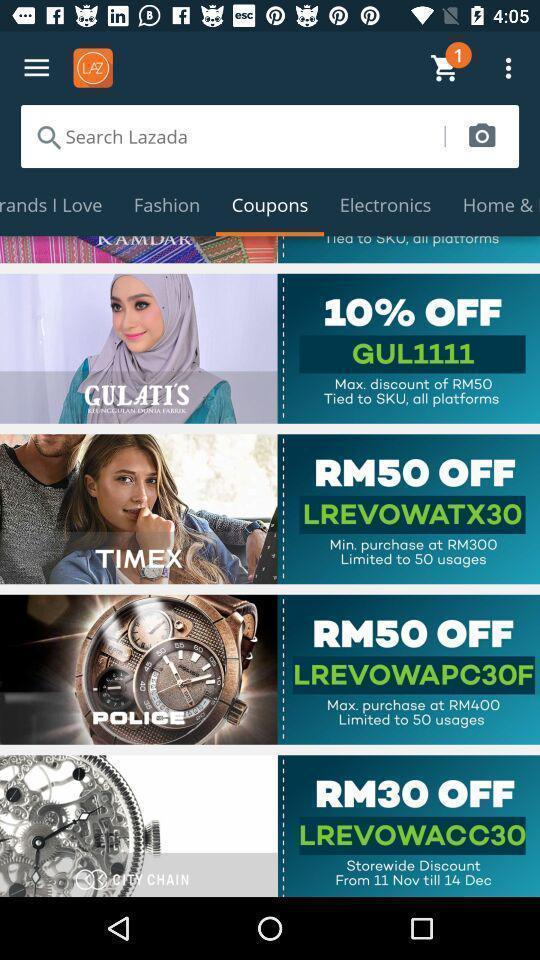Please provide a description for this image. Screen showing coupons page of a shopping app. 